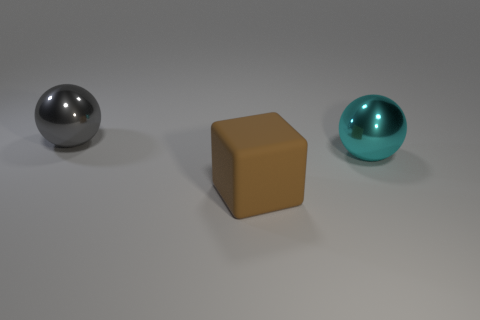What shape is the object in front of the big shiny sphere right of the metal sphere that is on the left side of the cyan metallic sphere?
Your response must be concise. Cube. There is a gray metallic ball; is its size the same as the shiny sphere that is to the right of the brown matte cube?
Provide a short and direct response. Yes. The large object that is behind the big brown cube and left of the large cyan shiny thing has what shape?
Your response must be concise. Sphere. What number of small objects are purple metallic cylinders or gray shiny balls?
Offer a terse response. 0. Are there an equal number of big blocks on the right side of the large cyan thing and large matte objects right of the large brown thing?
Offer a very short reply. Yes. Are there an equal number of big things that are to the right of the big brown rubber object and shiny balls?
Ensure brevity in your answer.  No. Do the brown thing and the cyan metal thing have the same size?
Offer a terse response. Yes. There is a thing that is right of the gray ball and behind the rubber object; what material is it?
Your response must be concise. Metal. What number of big gray objects have the same shape as the cyan object?
Ensure brevity in your answer.  1. What is the material of the sphere that is behind the large cyan shiny sphere?
Keep it short and to the point. Metal. 